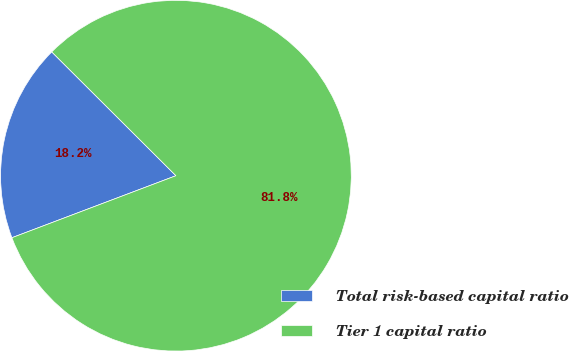Convert chart to OTSL. <chart><loc_0><loc_0><loc_500><loc_500><pie_chart><fcel>Total risk-based capital ratio<fcel>Tier 1 capital ratio<nl><fcel>18.23%<fcel>81.77%<nl></chart> 